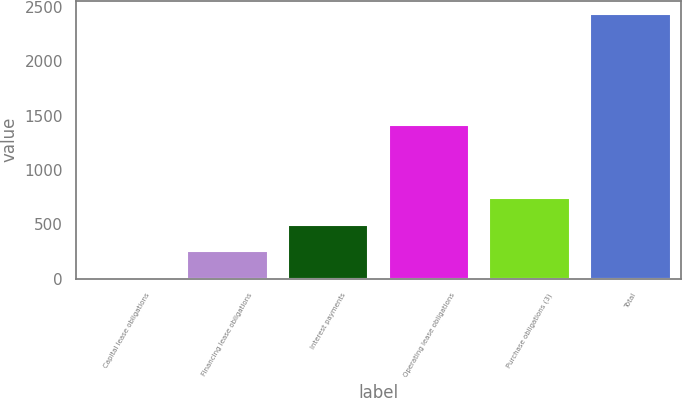Convert chart to OTSL. <chart><loc_0><loc_0><loc_500><loc_500><bar_chart><fcel>Capital lease obligations<fcel>Financing lease obligations<fcel>Interest payments<fcel>Operating lease obligations<fcel>Purchase obligations (3)<fcel>Total<nl><fcel>16<fcel>257.7<fcel>499.4<fcel>1412<fcel>741.1<fcel>2433<nl></chart> 